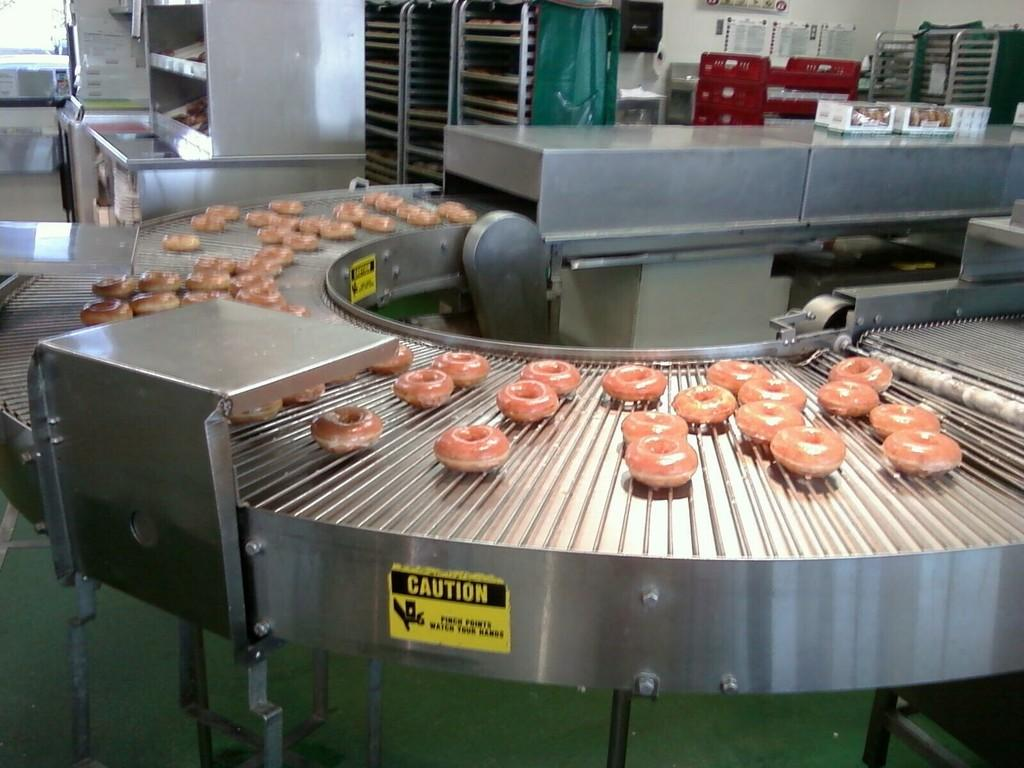<image>
Present a compact description of the photo's key features. a donut bakery that has a caution label on the side of one of the machines 